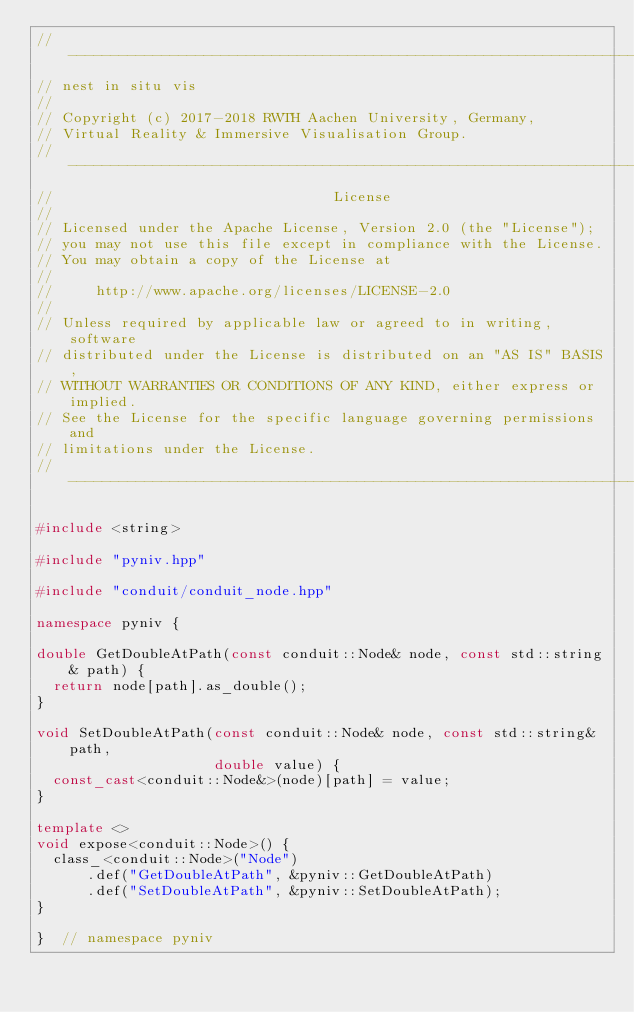Convert code to text. <code><loc_0><loc_0><loc_500><loc_500><_C++_>//------------------------------------------------------------------------------
// nest in situ vis
//
// Copyright (c) 2017-2018 RWTH Aachen University, Germany,
// Virtual Reality & Immersive Visualisation Group.
//------------------------------------------------------------------------------
//                                 License
//
// Licensed under the Apache License, Version 2.0 (the "License");
// you may not use this file except in compliance with the License.
// You may obtain a copy of the License at
//
//     http://www.apache.org/licenses/LICENSE-2.0
//
// Unless required by applicable law or agreed to in writing, software
// distributed under the License is distributed on an "AS IS" BASIS,
// WITHOUT WARRANTIES OR CONDITIONS OF ANY KIND, either express or implied.
// See the License for the specific language governing permissions and
// limitations under the License.
//------------------------------------------------------------------------------

#include <string>

#include "pyniv.hpp"

#include "conduit/conduit_node.hpp"

namespace pyniv {

double GetDoubleAtPath(const conduit::Node& node, const std::string& path) {
  return node[path].as_double();
}

void SetDoubleAtPath(const conduit::Node& node, const std::string& path,
                     double value) {
  const_cast<conduit::Node&>(node)[path] = value;
}

template <>
void expose<conduit::Node>() {
  class_<conduit::Node>("Node")
      .def("GetDoubleAtPath", &pyniv::GetDoubleAtPath)
      .def("SetDoubleAtPath", &pyniv::SetDoubleAtPath);
}

}  // namespace pyniv
</code> 